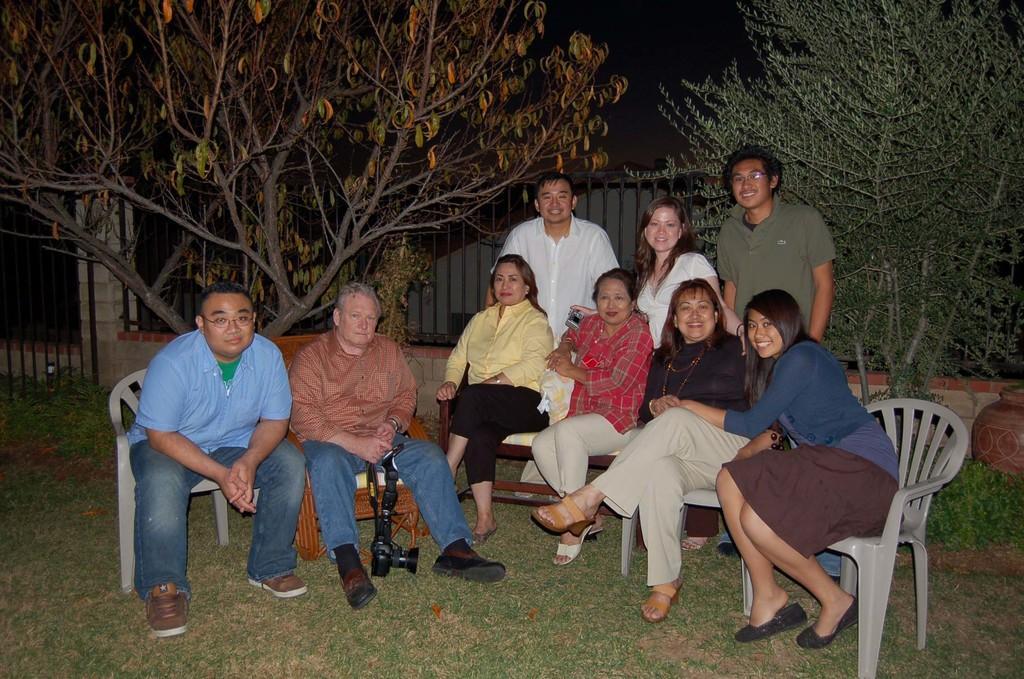In one or two sentences, can you explain what this image depicts? In this picture we can see some people are sitting on chairs, at the bottom there is grass, a man in the middle is holding a camera, in the background there are some trees, we can see the sky at the top of the picture, there is fencing panel in the middle. 